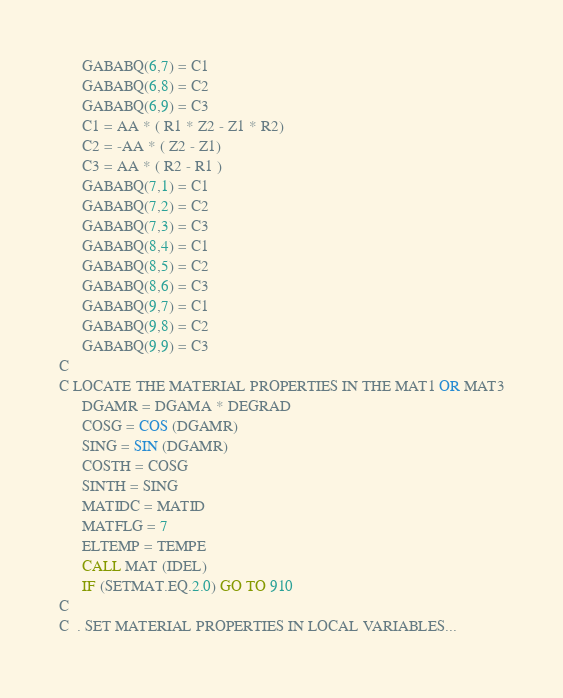<code> <loc_0><loc_0><loc_500><loc_500><_FORTRAN_>      GABABQ(6,7) = C1
      GABABQ(6,8) = C2
      GABABQ(6,9) = C3
      C1 = AA * ( R1 * Z2 - Z1 * R2)
      C2 = -AA * ( Z2 - Z1)
      C3 = AA * ( R2 - R1 )
      GABABQ(7,1) = C1
      GABABQ(7,2) = C2
      GABABQ(7,3) = C3
      GABABQ(8,4) = C1
      GABABQ(8,5) = C2
      GABABQ(8,6) = C3
      GABABQ(9,7) = C1
      GABABQ(9,8) = C2
      GABABQ(9,9) = C3
C
C LOCATE THE MATERIAL PROPERTIES IN THE MAT1 OR MAT3
      DGAMR = DGAMA * DEGRAD
      COSG = COS (DGAMR)
      SING = SIN (DGAMR)
      COSTH = COSG
      SINTH = SING
      MATIDC = MATID
      MATFLG = 7
      ELTEMP = TEMPE
      CALL MAT (IDEL)
      IF (SETMAT.EQ.2.0) GO TO 910
C
C  . SET MATERIAL PROPERTIES IN LOCAL VARIABLES...</code> 